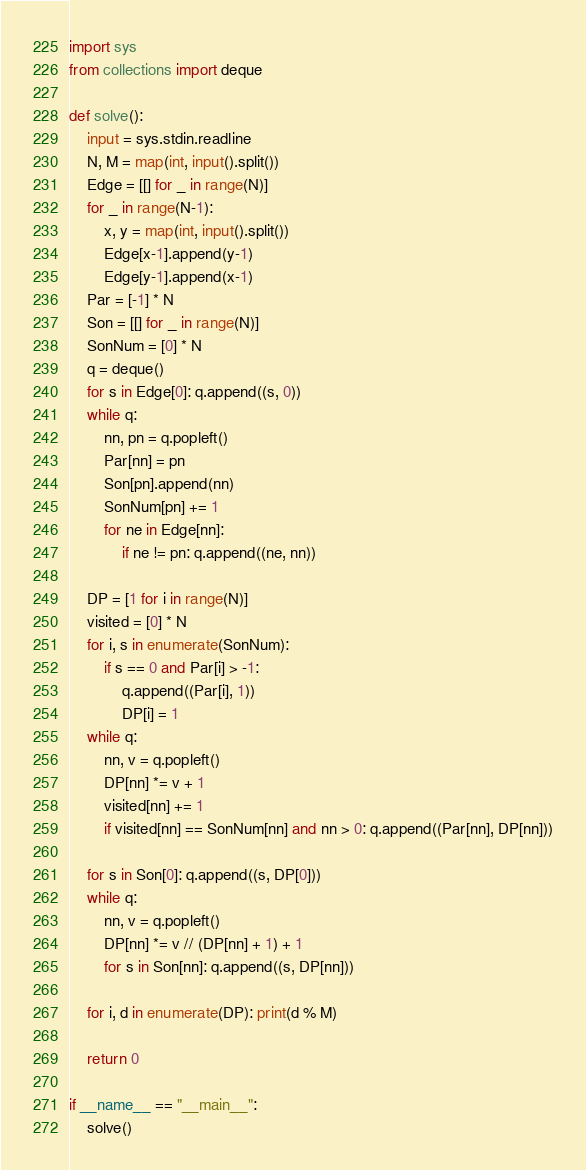<code> <loc_0><loc_0><loc_500><loc_500><_Python_>import sys
from collections import deque

def solve():
    input = sys.stdin.readline
    N, M = map(int, input().split())
    Edge = [[] for _ in range(N)]
    for _ in range(N-1):
        x, y = map(int, input().split())
        Edge[x-1].append(y-1)
        Edge[y-1].append(x-1)
    Par = [-1] * N
    Son = [[] for _ in range(N)]
    SonNum = [0] * N
    q = deque()
    for s in Edge[0]: q.append((s, 0))
    while q:
        nn, pn = q.popleft()
        Par[nn] = pn
        Son[pn].append(nn)
        SonNum[pn] += 1
        for ne in Edge[nn]:
            if ne != pn: q.append((ne, nn))

    DP = [1 for i in range(N)]
    visited = [0] * N
    for i, s in enumerate(SonNum):
        if s == 0 and Par[i] > -1:
            q.append((Par[i], 1))
            DP[i] = 1
    while q:
        nn, v = q.popleft()
        DP[nn] *= v + 1
        visited[nn] += 1
        if visited[nn] == SonNum[nn] and nn > 0: q.append((Par[nn], DP[nn]))

    for s in Son[0]: q.append((s, DP[0]))
    while q:
        nn, v = q.popleft()
        DP[nn] *= v // (DP[nn] + 1) + 1
        for s in Son[nn]: q.append((s, DP[nn]))

    for i, d in enumerate(DP): print(d % M)

    return 0

if __name__ == "__main__":
    solve()</code> 